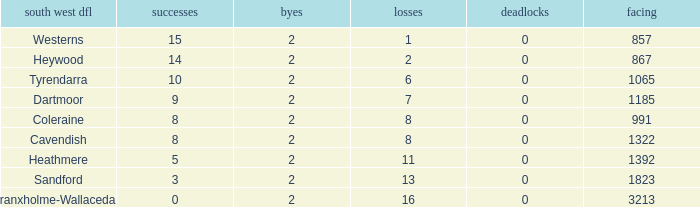How many Draws have a South West DFL of tyrendarra, and less than 10 wins? None. 